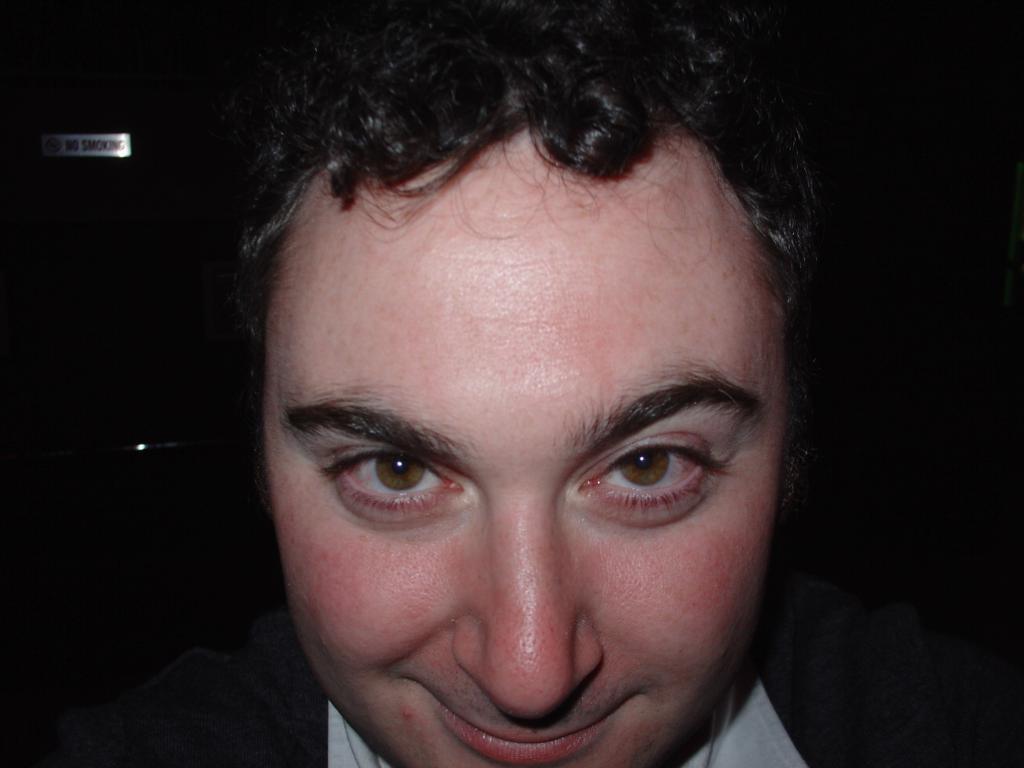How would you summarize this image in a sentence or two? In the foreground of this picture, there is a man having smile on his face. The background is dark with light focus of a sign board. 